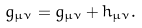Convert formula to latex. <formula><loc_0><loc_0><loc_500><loc_500>g _ { \mu \nu } = { \bar { g } } _ { \mu \nu } + h _ { \mu \nu } .</formula> 